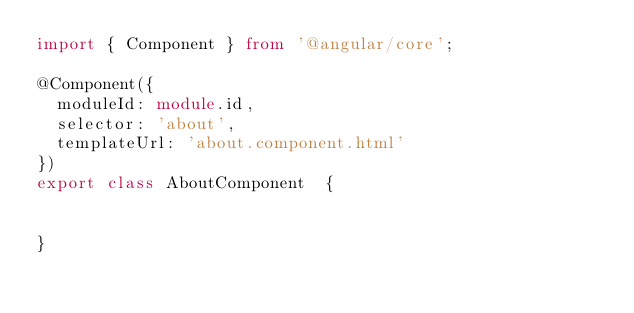<code> <loc_0><loc_0><loc_500><loc_500><_TypeScript_>import { Component } from '@angular/core';

@Component({
  moduleId: module.id,
  selector: 'about',
  templateUrl: 'about.component.html'
})
export class AboutComponent  {


}
</code> 